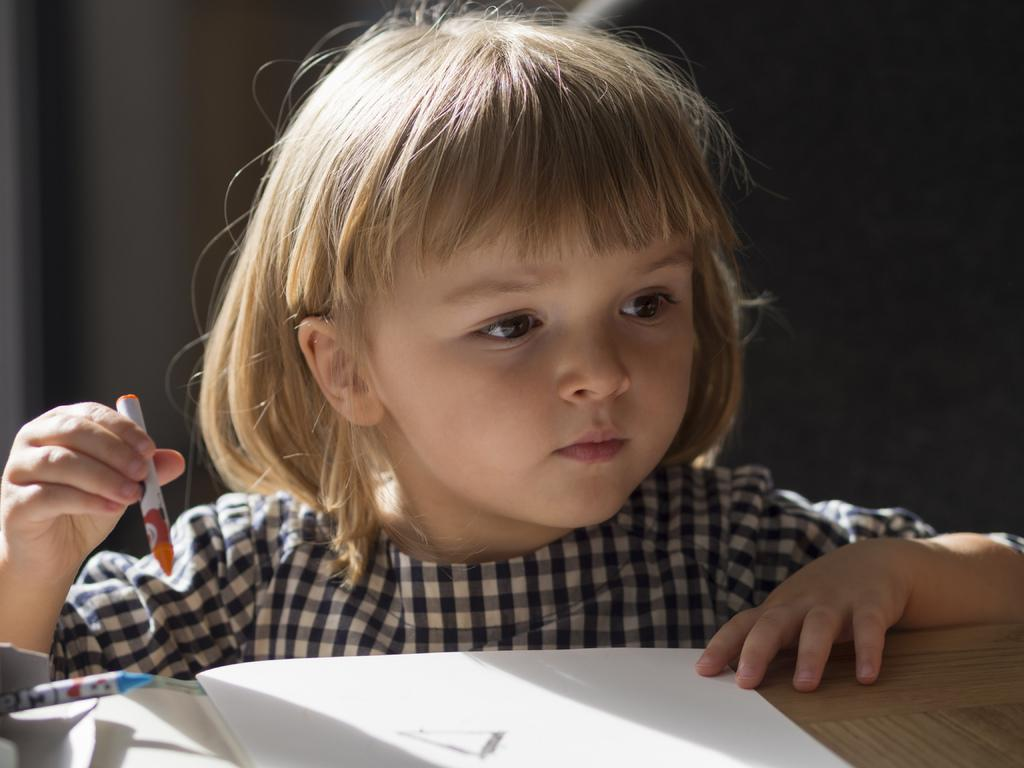Who is the main subject in the image? There is a small girl in the image. What is the girl doing in the image? The girl is drawing in a book. What is the girl wearing in the image? The girl is wearing a black and white dress. What is in front of the girl in the image? There is a table in front of the girl. What is on the table in the image? There is a book on the table. What type of cable is connected to the girl's drawing in the image? There is no cable connected to the girl's drawing in the image. 